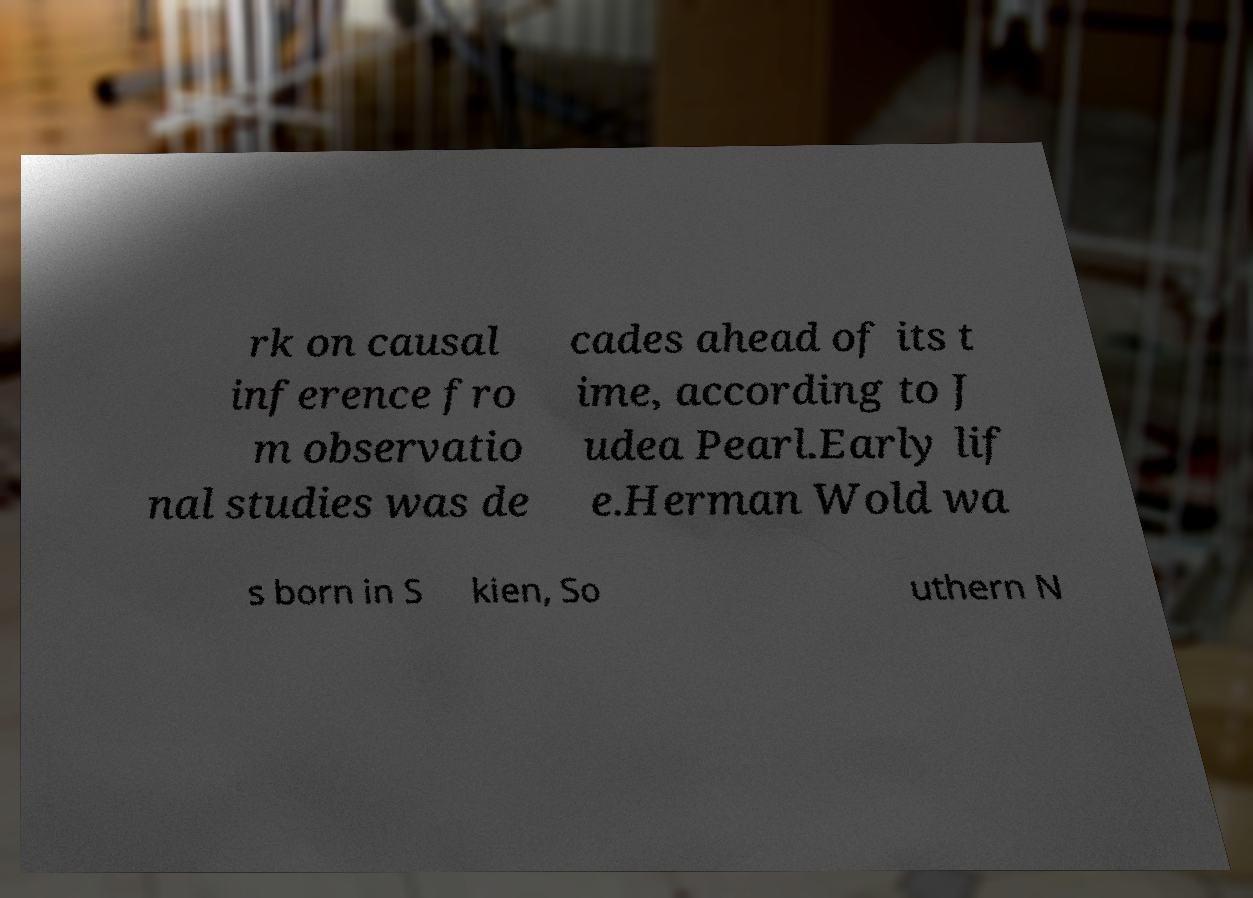Please identify and transcribe the text found in this image. rk on causal inference fro m observatio nal studies was de cades ahead of its t ime, according to J udea Pearl.Early lif e.Herman Wold wa s born in S kien, So uthern N 